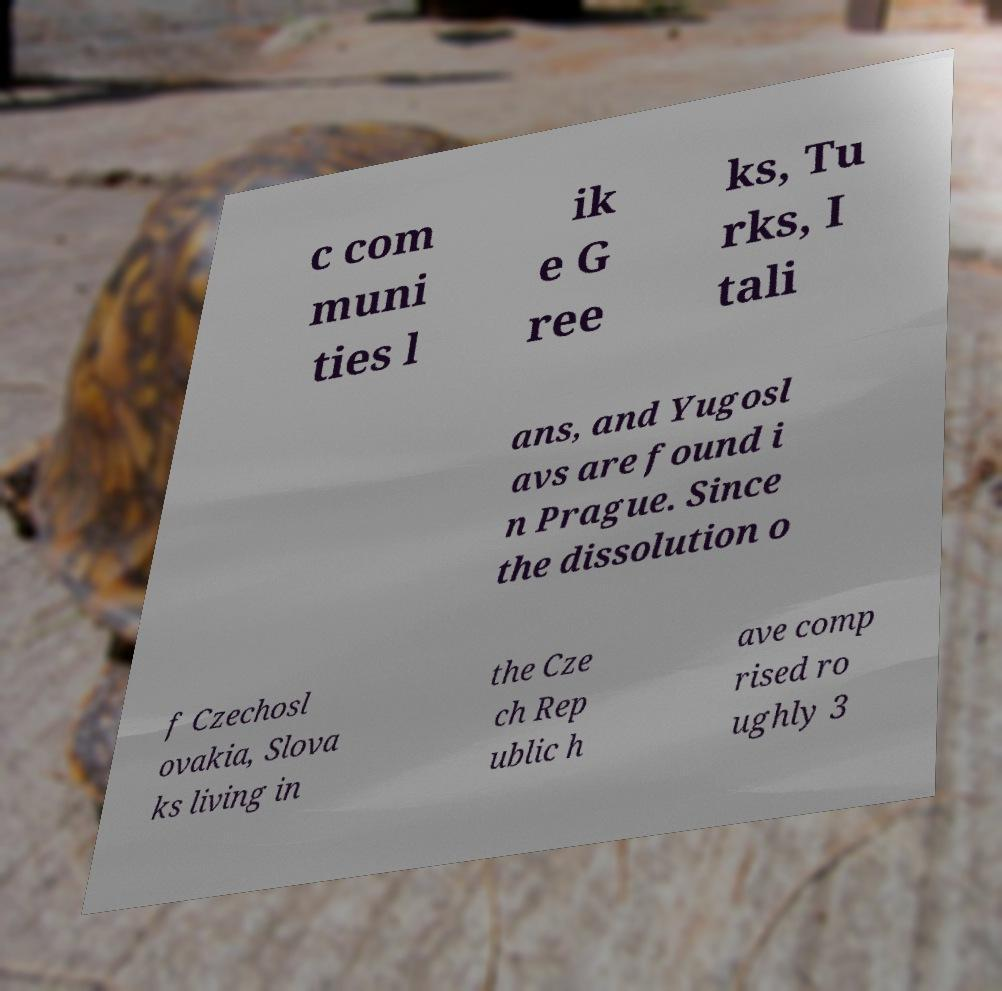Can you accurately transcribe the text from the provided image for me? c com muni ties l ik e G ree ks, Tu rks, I tali ans, and Yugosl avs are found i n Prague. Since the dissolution o f Czechosl ovakia, Slova ks living in the Cze ch Rep ublic h ave comp rised ro ughly 3 